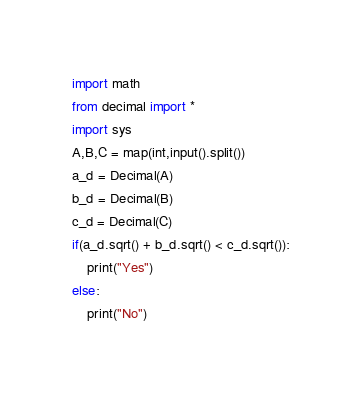Convert code to text. <code><loc_0><loc_0><loc_500><loc_500><_Python_>import math
from decimal import *
import sys
A,B,C = map(int,input().split())
a_d = Decimal(A)
b_d = Decimal(B)
c_d = Decimal(C)
if(a_d.sqrt() + b_d.sqrt() < c_d.sqrt()):
    print("Yes")
else:
    print("No")</code> 